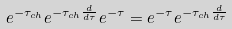Convert formula to latex. <formula><loc_0><loc_0><loc_500><loc_500>e ^ { - \tau _ { c h } } e ^ { - \tau _ { c h } \frac { d } { d \tau } } e ^ { - \tau } = e ^ { - \tau } e ^ { - \tau _ { c h } \frac { d } { d \tau } }</formula> 